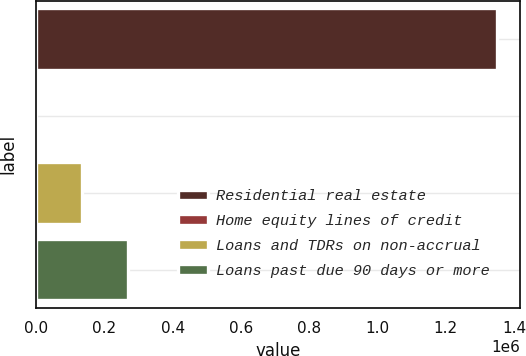Convert chart to OTSL. <chart><loc_0><loc_0><loc_500><loc_500><bar_chart><fcel>Residential real estate<fcel>Home equity lines of credit<fcel>Loans and TDRs on non-accrual<fcel>Loans past due 90 days or more<nl><fcel>1.35061e+06<fcel>280<fcel>135313<fcel>270346<nl></chart> 